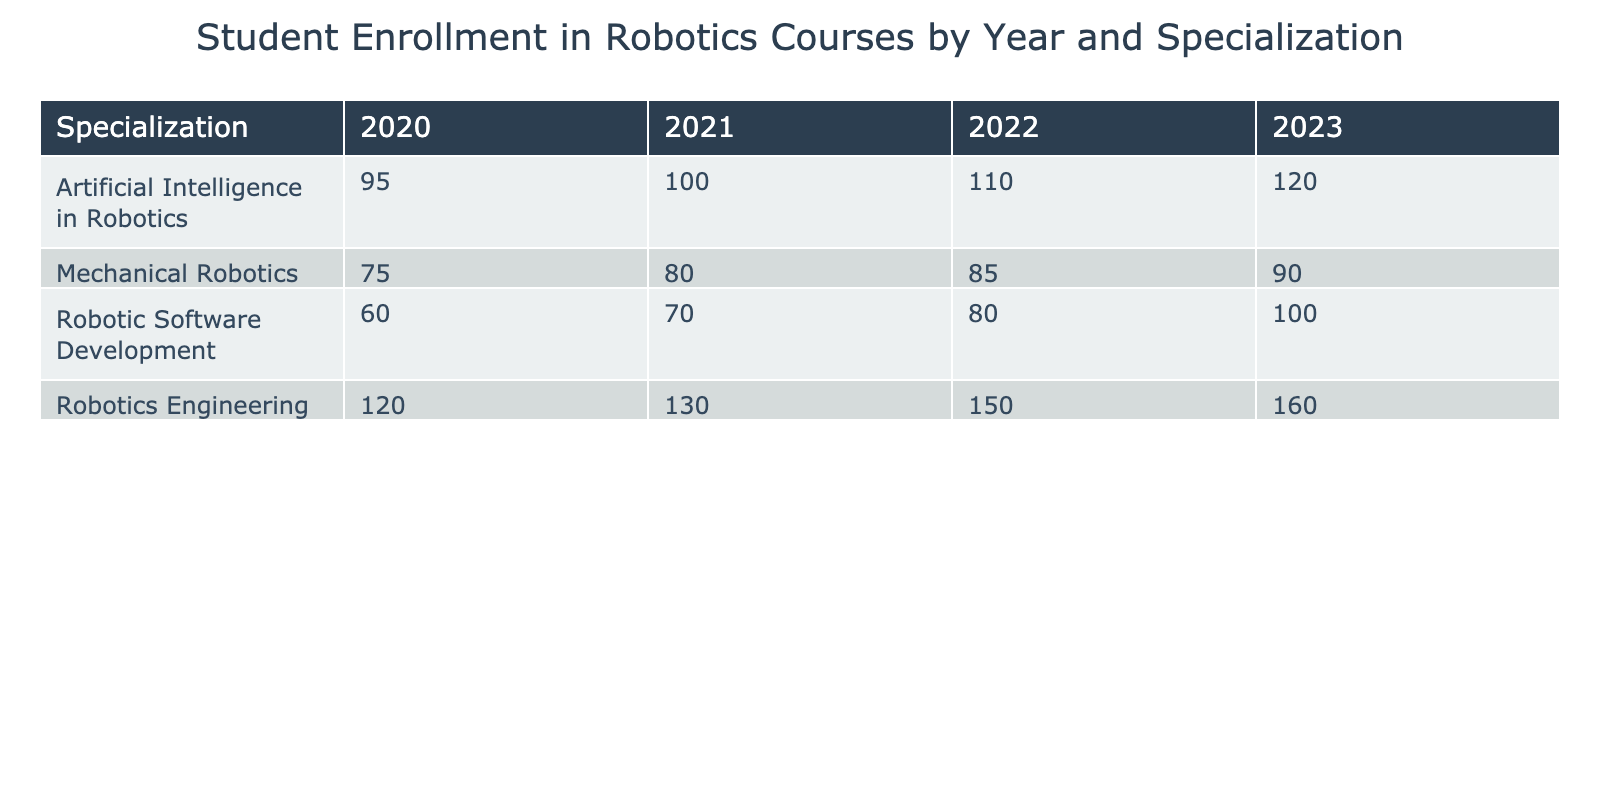What was the enrollment count for Robotics Engineering in 2021? The table indicates that in 2021, the enrollment count for Robotics Engineering is listed under the corresponding year and specialization as 130.
Answer: 130 Which specialization had the highest enrollment in 2022? By looking at the enrollment counts for each specialization in 2022, Robotics Engineering had the highest enrollment count of 150 compared to others (AI in Robotics = 110, Mechanical Robotics = 85, Robotic Software Development = 80).
Answer: Robotics Engineering What is the total enrollment for all specializations in 2023? To calculate total enrollment for 2023, we sum the counts: Robotics Engineering (160) + AI in Robotics (120) + Mechanical Robotics (90) + Robotic Software Development (100) = 470.
Answer: 470 Did the enrollment count for Robotic Software Development increase from 2020 to 2023? In 2020, the enrollment count for Robotic Software Development was 60, and in 2023, it was 100. Since 100 is greater than 60, we conclude that the enrollment did increase.
Answer: Yes What was the average enrollment count across all specializations in 2020? In 2020, the enrollment counts for each specialization were 120, 95, 75, and 60. The sum is 120 + 95 + 75 + 60 = 350. Dividing this by the number of specializations (4) gives us an average of 350 / 4 = 87.5.
Answer: 87.5 Which year saw the lowest total enrollment across all specializations? First, we calculate total enrollment for each year: 2020 = 120 + 95 + 75 + 60 = 350, 2021 = 130 + 100 + 80 + 70 = 380, 2022 = 150 + 110 + 85 + 80 = 425, and 2023 = 160 + 120 + 90 + 100 = 470. The year with the lowest total is 2020 with 350.
Answer: 2020 Is the enrollment for Artificial Intelligence in Robotics consistently increasing from 2020 to 2023? The enrollment counts are 95 in 2020, 100 in 2021, 110 in 2022, and 120 in 2023. Since each year shows an increase over the previous year, we conclude that it is consistently increasing.
Answer: Yes What is the difference in enrollment for Mechanical Robotics between 2022 and 2023? In 2022, the enrollment for Mechanical Robotics is 85 and in 2023 it is 90. The difference is calculated as 90 - 85 = 5.
Answer: 5 